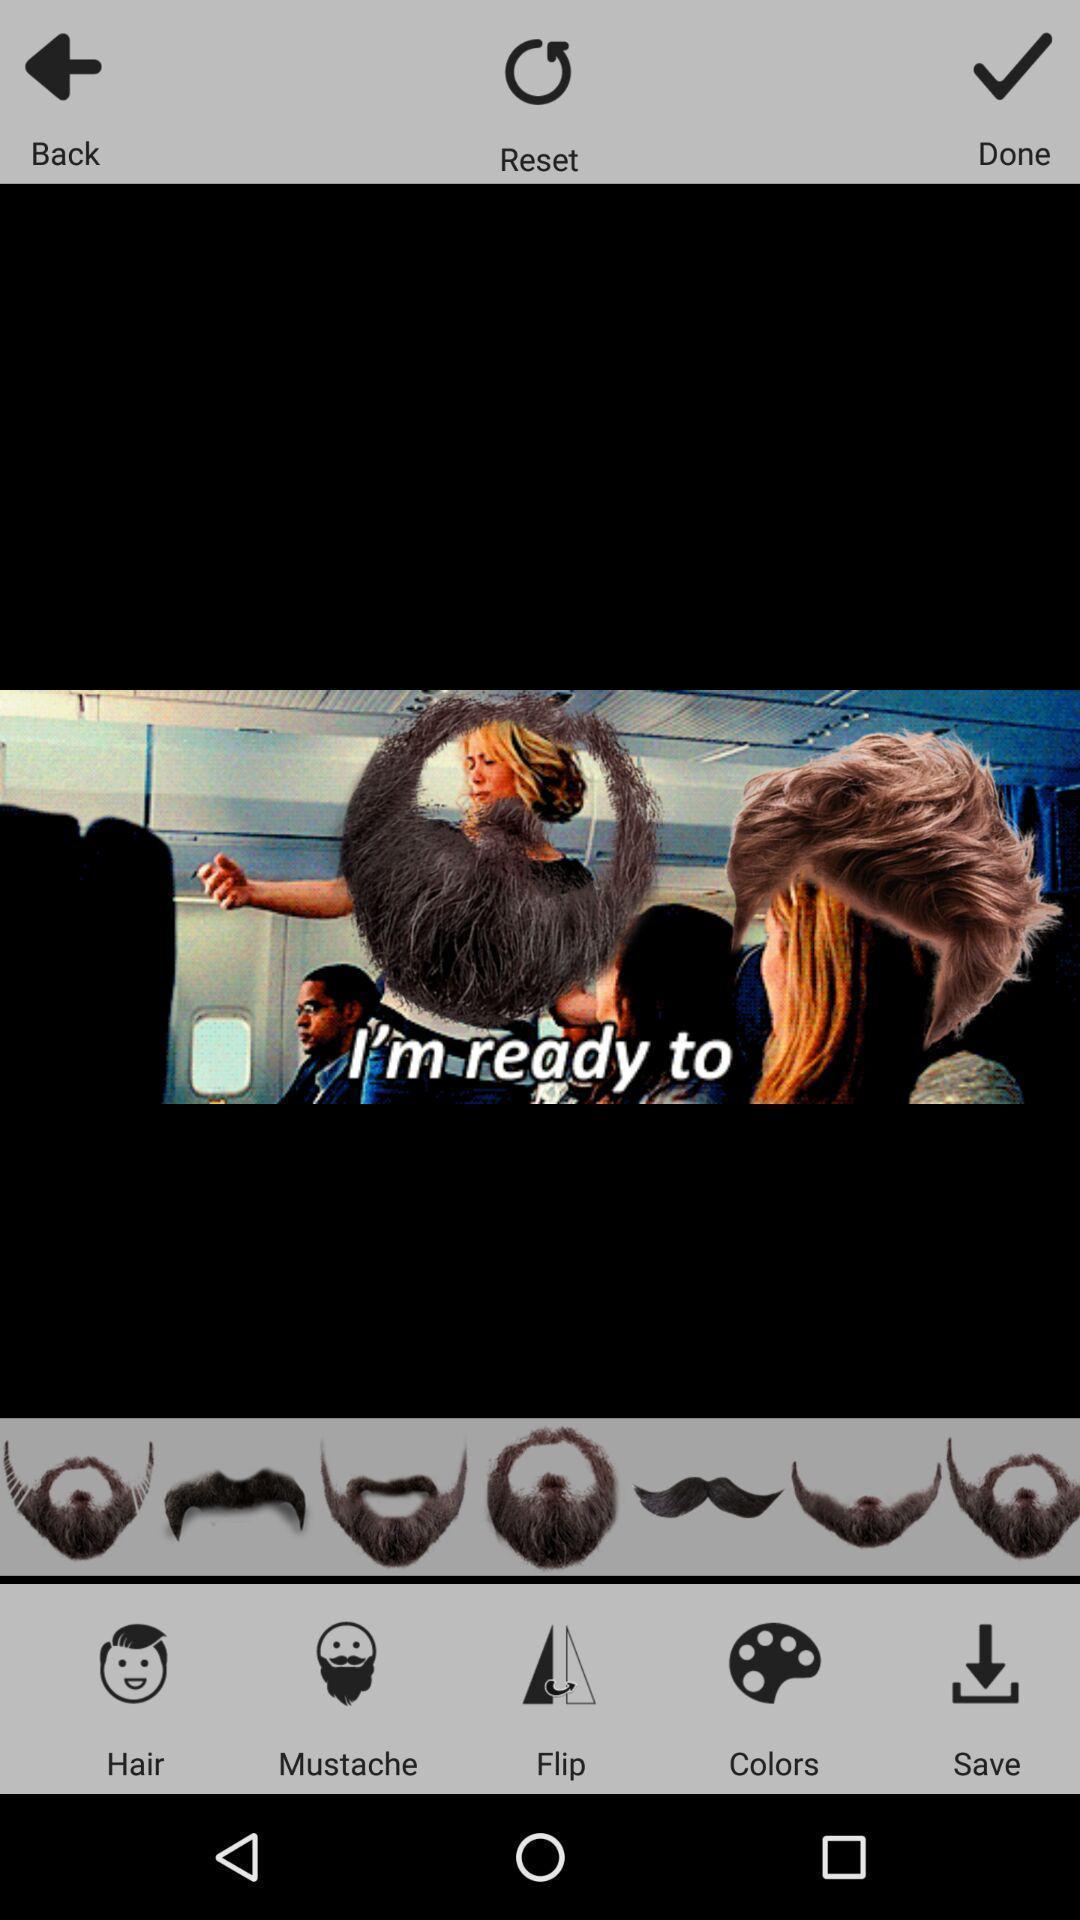Provide a textual representation of this image. Page showing various editing options. 